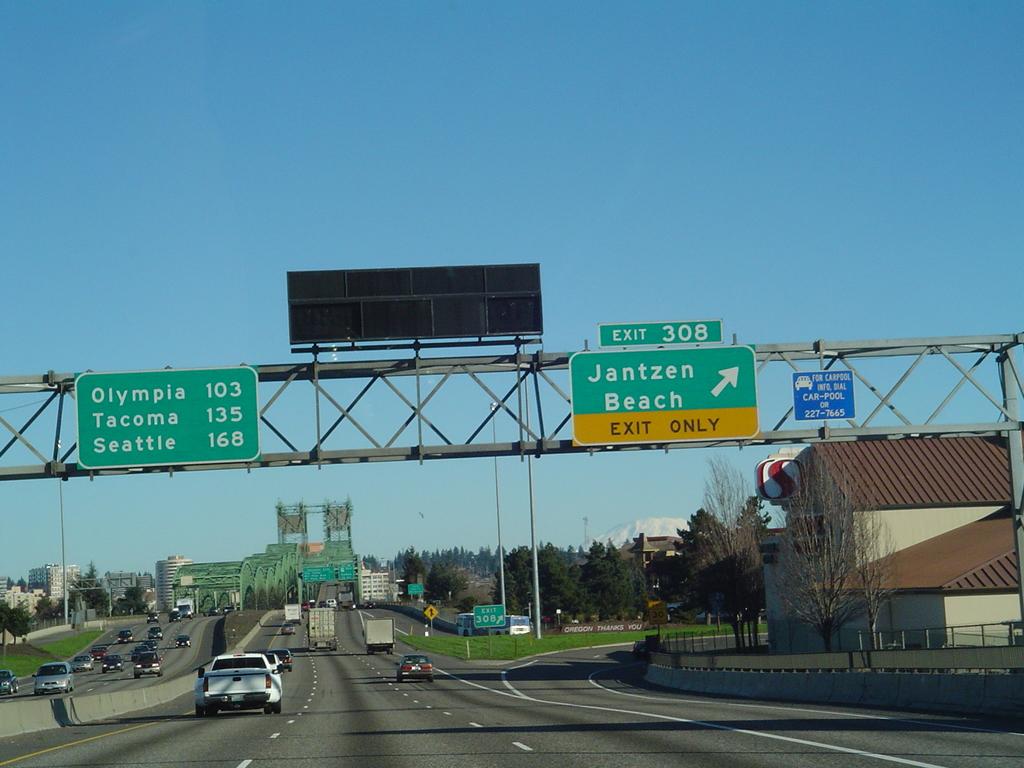How far is tacoma?
Make the answer very short. 135. 